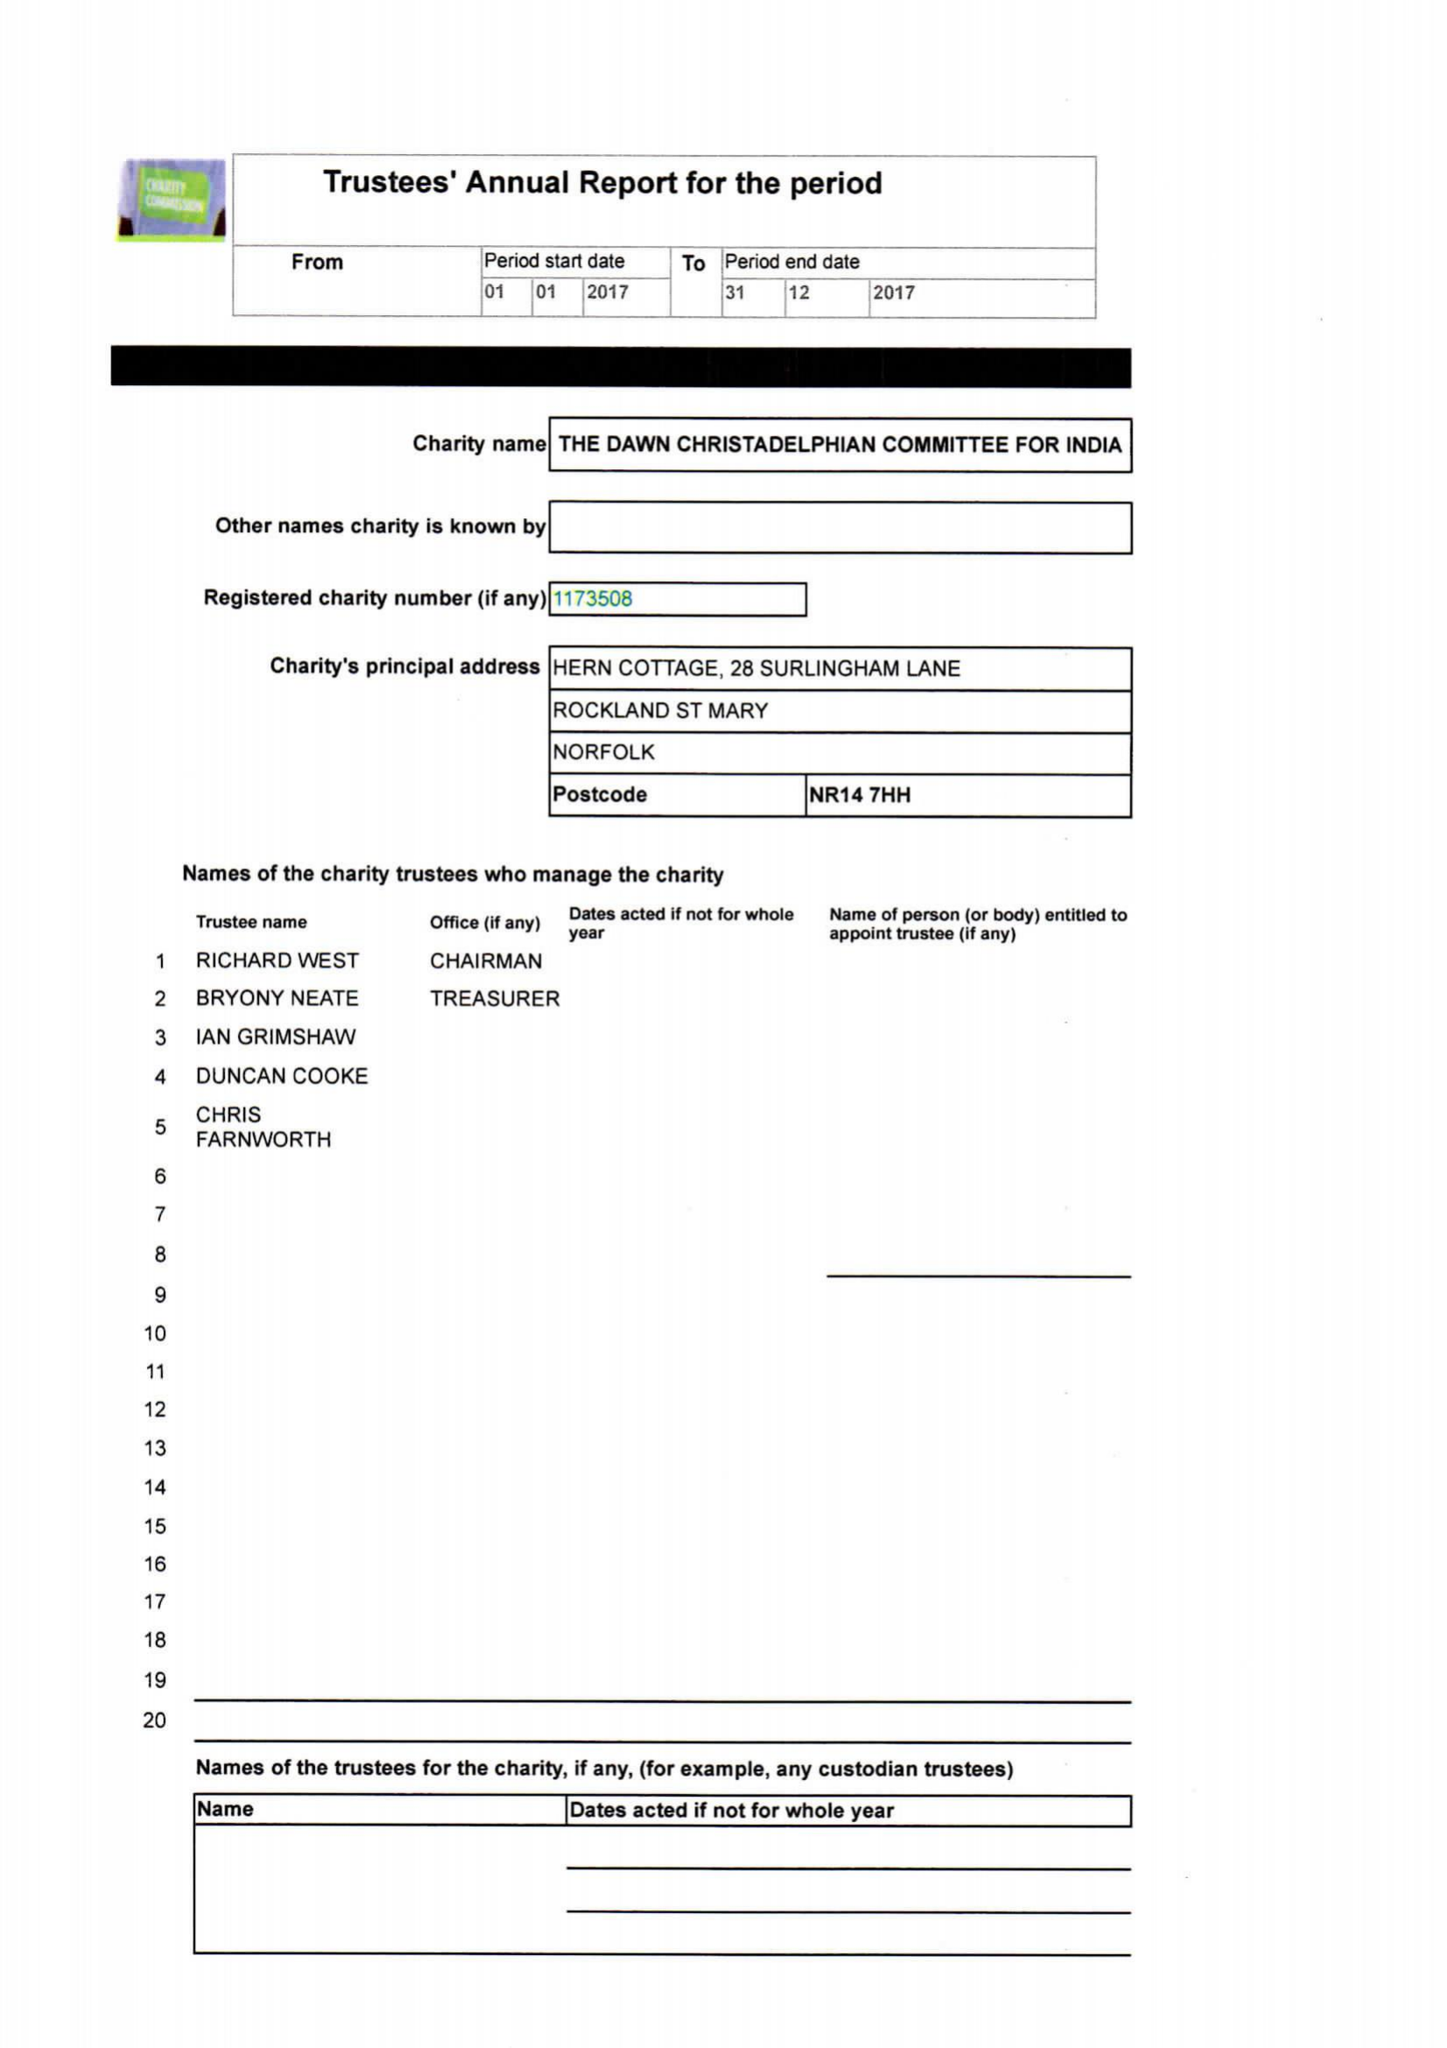What is the value for the spending_annually_in_british_pounds?
Answer the question using a single word or phrase. 25236.00 